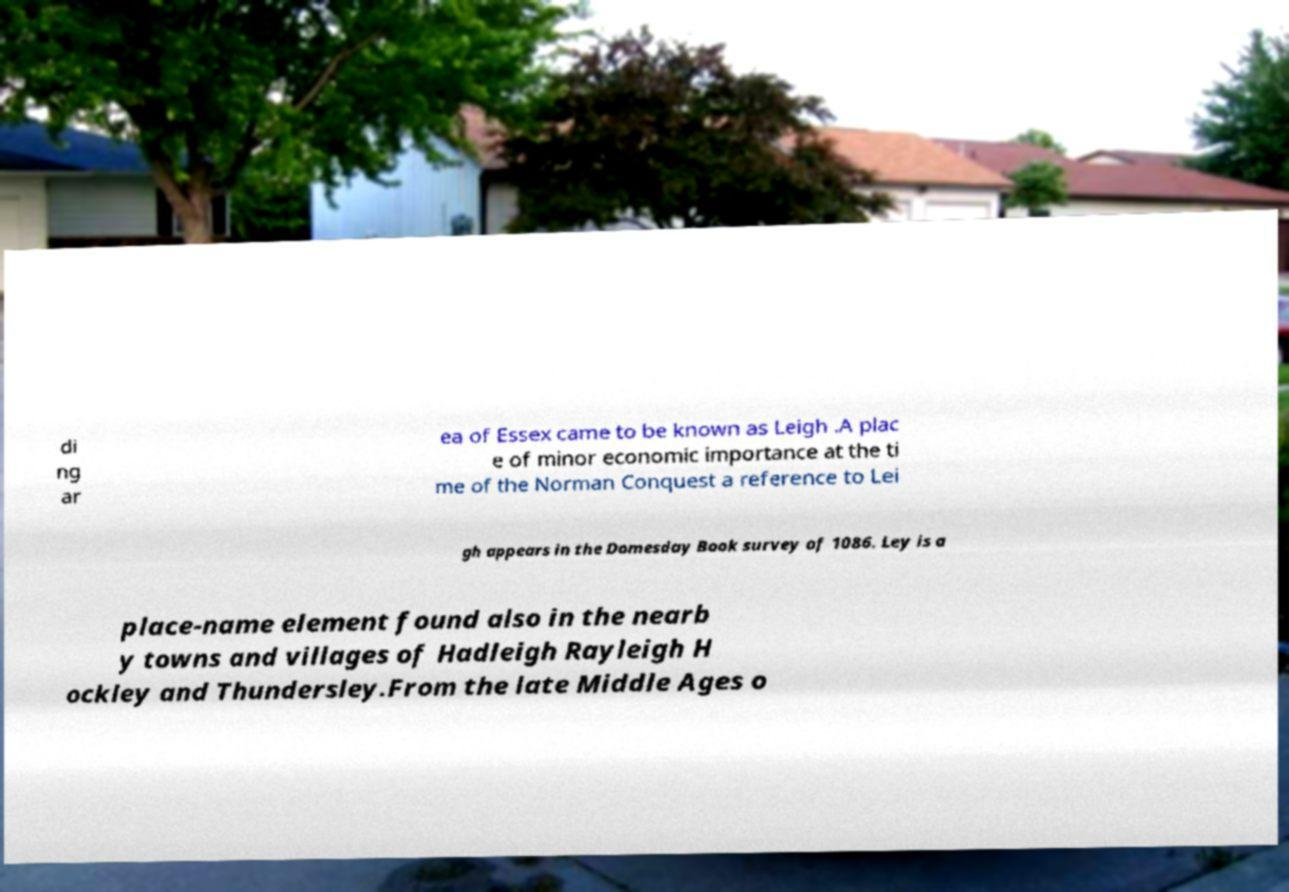For documentation purposes, I need the text within this image transcribed. Could you provide that? di ng ar ea of Essex came to be known as Leigh .A plac e of minor economic importance at the ti me of the Norman Conquest a reference to Lei gh appears in the Domesday Book survey of 1086. Ley is a place-name element found also in the nearb y towns and villages of Hadleigh Rayleigh H ockley and Thundersley.From the late Middle Ages o 